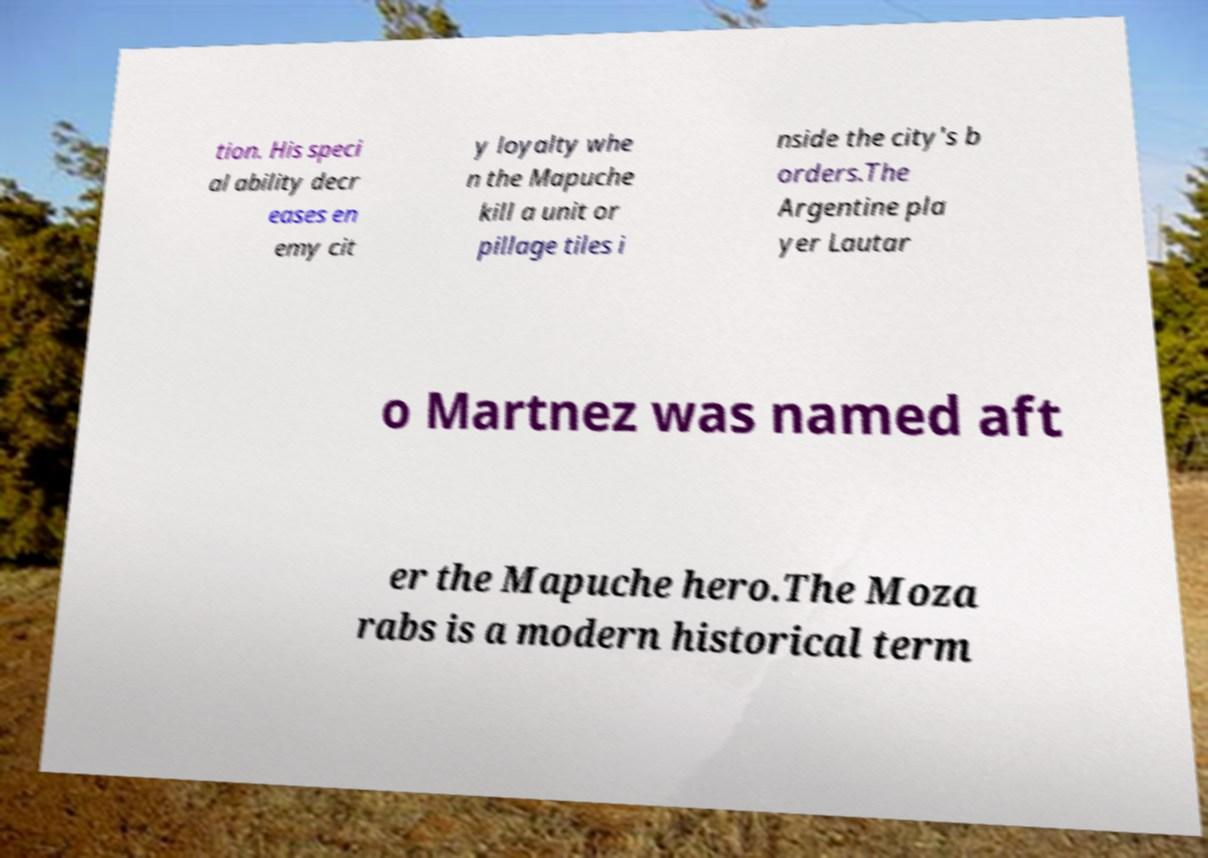Could you extract and type out the text from this image? tion. His speci al ability decr eases en emy cit y loyalty whe n the Mapuche kill a unit or pillage tiles i nside the city's b orders.The Argentine pla yer Lautar o Martnez was named aft er the Mapuche hero.The Moza rabs is a modern historical term 